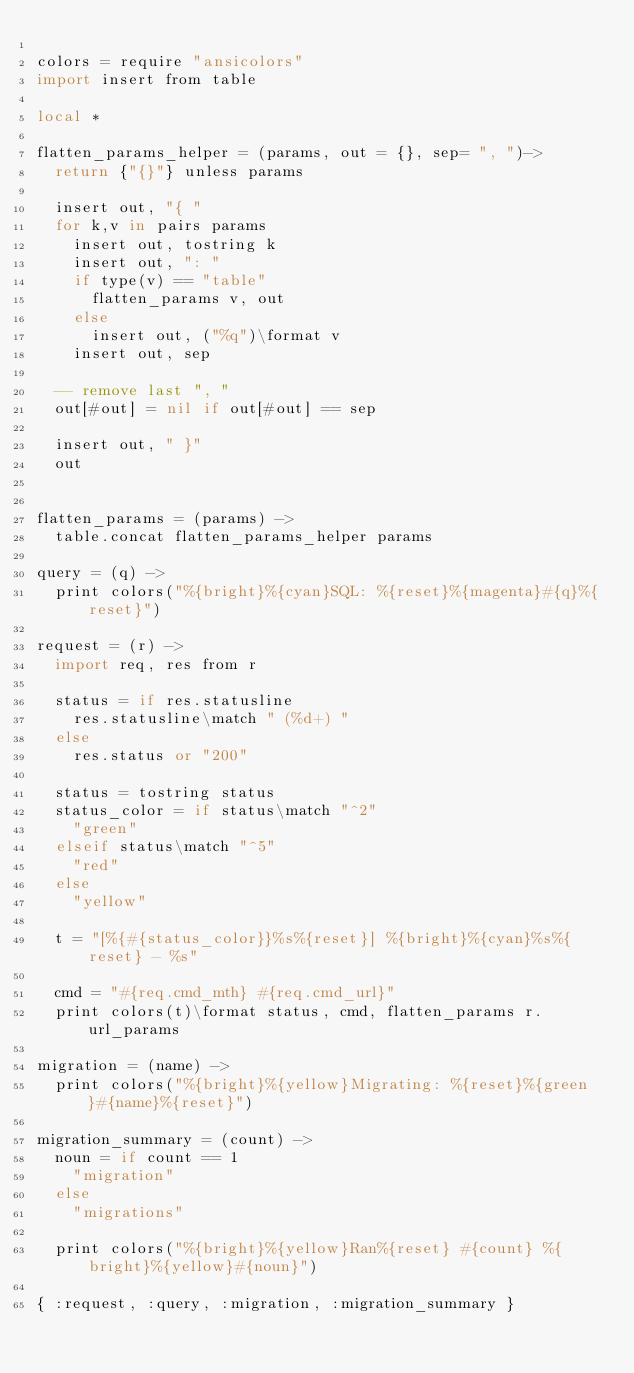Convert code to text. <code><loc_0><loc_0><loc_500><loc_500><_MoonScript_>
colors = require "ansicolors"
import insert from table

local *

flatten_params_helper = (params, out = {}, sep= ", ")->
  return {"{}"} unless params

  insert out, "{ "
  for k,v in pairs params
    insert out, tostring k
    insert out, ": "
    if type(v) == "table"
      flatten_params v, out
    else
      insert out, ("%q")\format v
    insert out, sep

  -- remove last ", "
  out[#out] = nil if out[#out] == sep

  insert out, " }"
  out


flatten_params = (params) ->
  table.concat flatten_params_helper params

query = (q) ->
  print colors("%{bright}%{cyan}SQL: %{reset}%{magenta}#{q}%{reset}")

request = (r) ->
  import req, res from r

  status = if res.statusline
    res.statusline\match " (%d+) "
  else
    res.status or "200"

  status = tostring status
  status_color = if status\match "^2"
    "green"
  elseif status\match "^5"
    "red"
  else
    "yellow"

  t = "[%{#{status_color}}%s%{reset}] %{bright}%{cyan}%s%{reset} - %s"

  cmd = "#{req.cmd_mth} #{req.cmd_url}"
  print colors(t)\format status, cmd, flatten_params r.url_params

migration = (name) ->
  print colors("%{bright}%{yellow}Migrating: %{reset}%{green}#{name}%{reset}")

migration_summary = (count) ->
  noun = if count == 1
    "migration"
  else
    "migrations"

  print colors("%{bright}%{yellow}Ran%{reset} #{count} %{bright}%{yellow}#{noun}")

{ :request, :query, :migration, :migration_summary }

</code> 